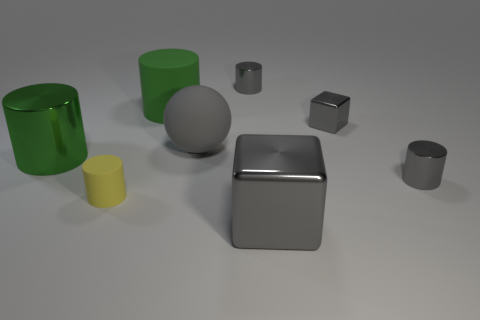Is there anything else that has the same shape as the large gray rubber object?
Your answer should be compact. No. Are the yellow object and the large green object that is behind the big gray rubber object made of the same material?
Your answer should be compact. Yes. Is the number of small shiny cylinders that are left of the tiny yellow rubber object less than the number of small gray cylinders to the right of the large gray shiny block?
Offer a very short reply. Yes. There is another block that is the same material as the large gray cube; what color is it?
Your response must be concise. Gray. There is a metallic cylinder that is behind the green metal object; is there a gray cylinder that is to the right of it?
Give a very brief answer. Yes. There is a matte object that is the same size as the gray rubber sphere; what color is it?
Offer a very short reply. Green. What number of things are small brown rubber cylinders or gray cylinders?
Offer a terse response. 2. There is a green cylinder behind the big metal thing left of the large matte object left of the large gray matte thing; what is its size?
Provide a short and direct response. Large. What number of metallic things are the same color as the small metallic cube?
Your answer should be very brief. 3. How many large gray blocks are made of the same material as the big ball?
Keep it short and to the point. 0. 